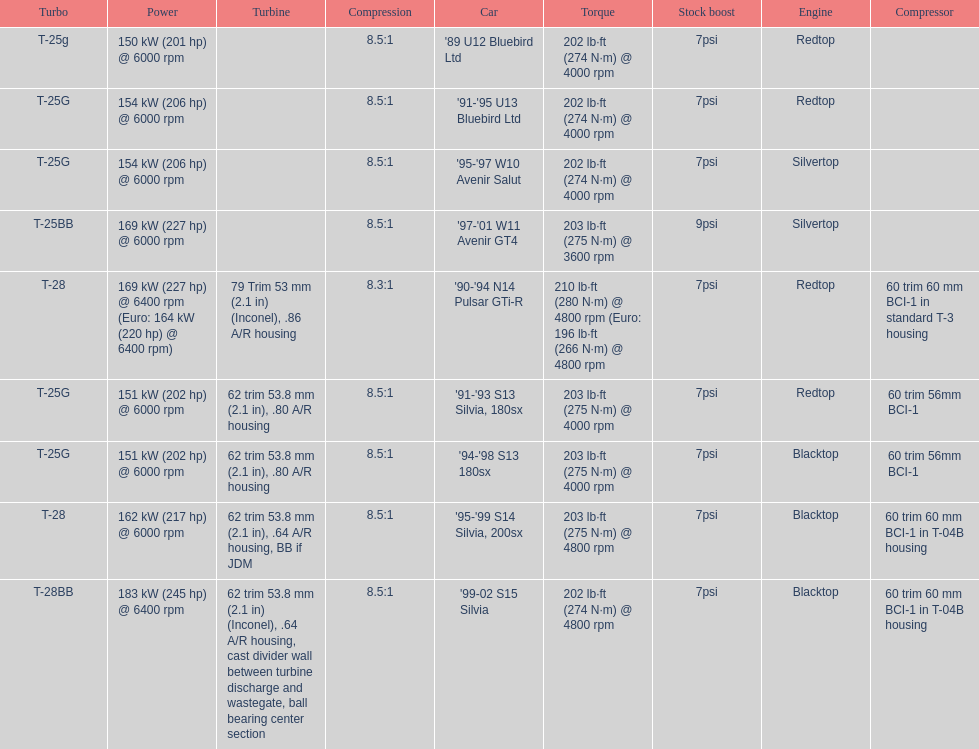How many models used the redtop engine? 4. 